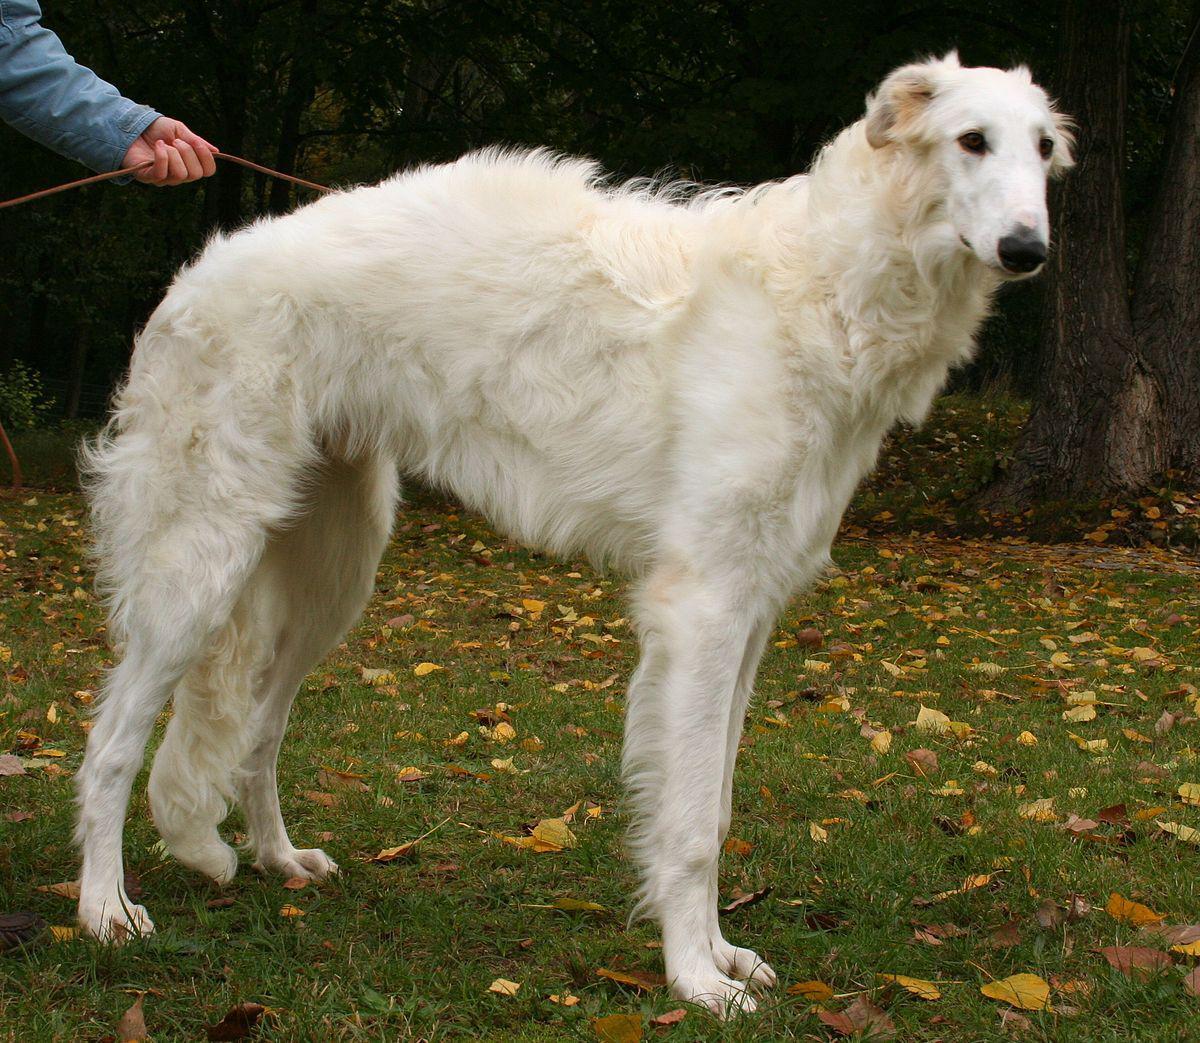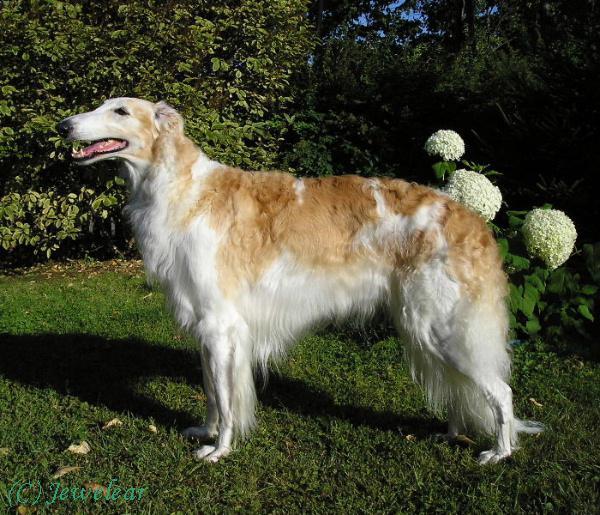The first image is the image on the left, the second image is the image on the right. For the images displayed, is the sentence "There is a human holding a dog's leash." factually correct? Answer yes or no. Yes. The first image is the image on the left, the second image is the image on the right. For the images shown, is this caption "In one of the images, a single white dog with no dark patches has its mouth open and is standing in green grass facing rightward." true? Answer yes or no. No. 